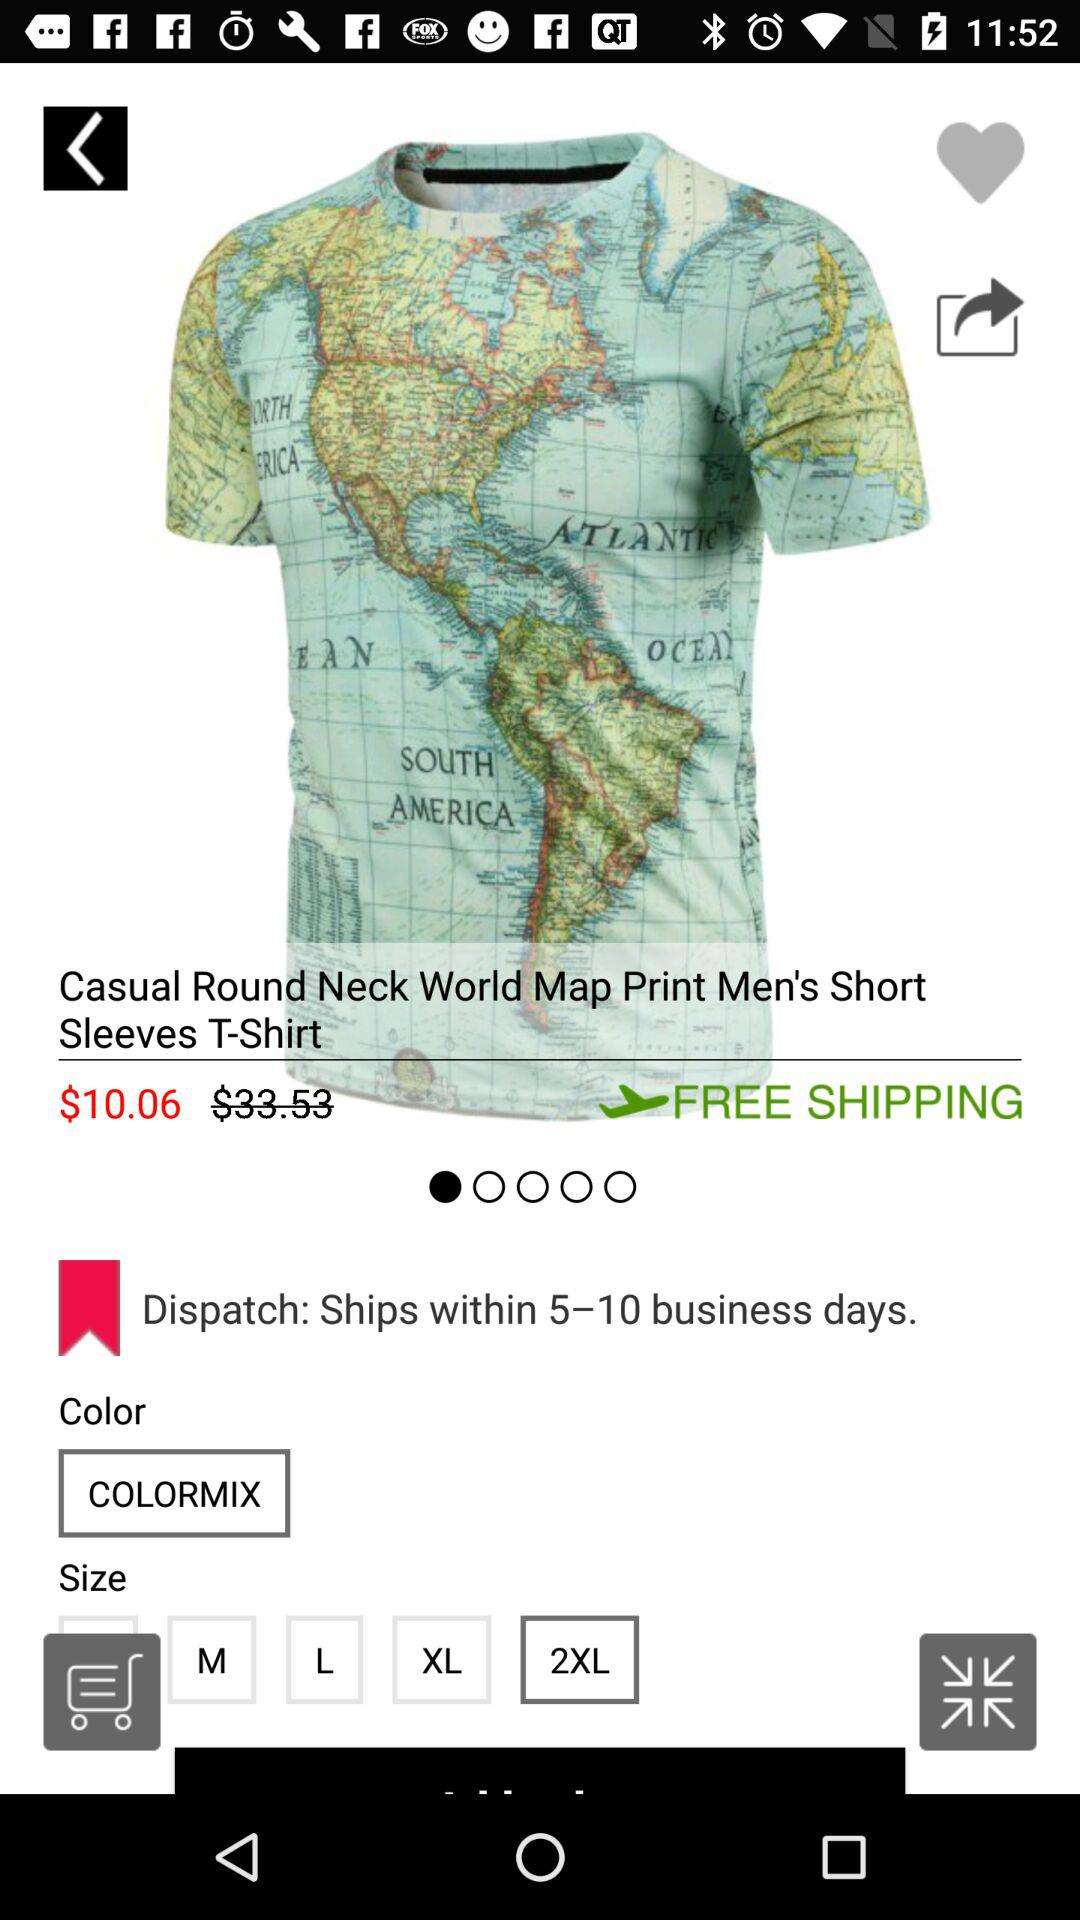How many sizes are available for this shirt?
Answer the question using a single word or phrase. 5 